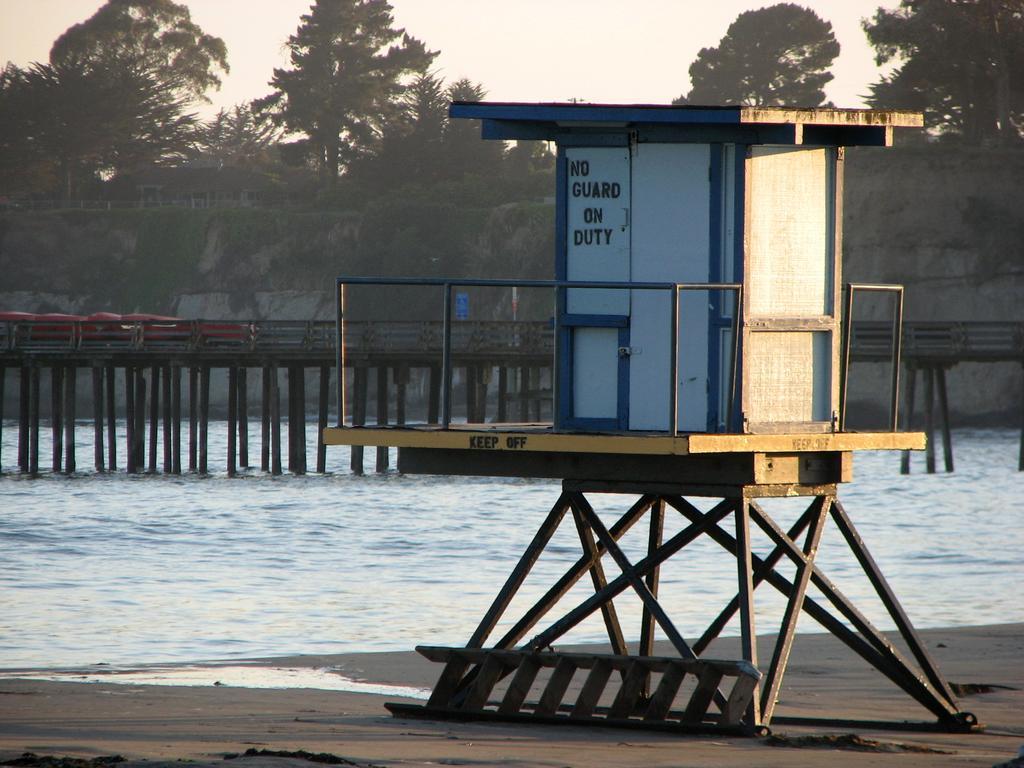How would you summarize this image in a sentence or two? In this picture I can see a safeguard room, there is a ladder, water, bridge, there are trees, and in the background there is sky. 